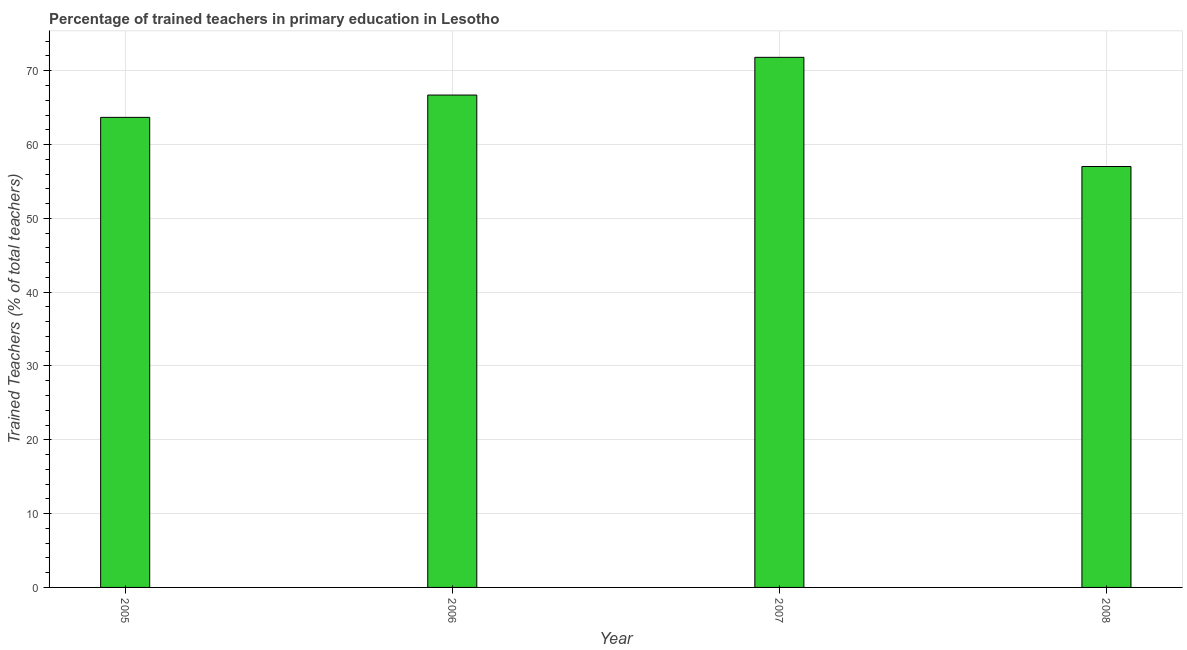Does the graph contain grids?
Ensure brevity in your answer.  Yes. What is the title of the graph?
Keep it short and to the point. Percentage of trained teachers in primary education in Lesotho. What is the label or title of the Y-axis?
Make the answer very short. Trained Teachers (% of total teachers). What is the percentage of trained teachers in 2006?
Ensure brevity in your answer.  66.7. Across all years, what is the maximum percentage of trained teachers?
Provide a short and direct response. 71.81. Across all years, what is the minimum percentage of trained teachers?
Make the answer very short. 57.02. What is the sum of the percentage of trained teachers?
Offer a terse response. 259.22. What is the difference between the percentage of trained teachers in 2005 and 2007?
Your response must be concise. -8.13. What is the average percentage of trained teachers per year?
Your response must be concise. 64.8. What is the median percentage of trained teachers?
Offer a terse response. 65.19. In how many years, is the percentage of trained teachers greater than 36 %?
Your answer should be compact. 4. What is the ratio of the percentage of trained teachers in 2005 to that in 2007?
Your response must be concise. 0.89. What is the difference between the highest and the second highest percentage of trained teachers?
Give a very brief answer. 5.11. What is the difference between the highest and the lowest percentage of trained teachers?
Give a very brief answer. 14.79. How many years are there in the graph?
Make the answer very short. 4. What is the Trained Teachers (% of total teachers) in 2005?
Keep it short and to the point. 63.68. What is the Trained Teachers (% of total teachers) in 2006?
Your answer should be compact. 66.7. What is the Trained Teachers (% of total teachers) in 2007?
Offer a very short reply. 71.81. What is the Trained Teachers (% of total teachers) of 2008?
Provide a short and direct response. 57.02. What is the difference between the Trained Teachers (% of total teachers) in 2005 and 2006?
Provide a short and direct response. -3.02. What is the difference between the Trained Teachers (% of total teachers) in 2005 and 2007?
Ensure brevity in your answer.  -8.13. What is the difference between the Trained Teachers (% of total teachers) in 2005 and 2008?
Your answer should be compact. 6.66. What is the difference between the Trained Teachers (% of total teachers) in 2006 and 2007?
Provide a succinct answer. -5.11. What is the difference between the Trained Teachers (% of total teachers) in 2006 and 2008?
Your response must be concise. 9.68. What is the difference between the Trained Teachers (% of total teachers) in 2007 and 2008?
Offer a terse response. 14.79. What is the ratio of the Trained Teachers (% of total teachers) in 2005 to that in 2006?
Offer a terse response. 0.95. What is the ratio of the Trained Teachers (% of total teachers) in 2005 to that in 2007?
Your answer should be compact. 0.89. What is the ratio of the Trained Teachers (% of total teachers) in 2005 to that in 2008?
Make the answer very short. 1.12. What is the ratio of the Trained Teachers (% of total teachers) in 2006 to that in 2007?
Give a very brief answer. 0.93. What is the ratio of the Trained Teachers (% of total teachers) in 2006 to that in 2008?
Your response must be concise. 1.17. What is the ratio of the Trained Teachers (% of total teachers) in 2007 to that in 2008?
Your answer should be very brief. 1.26. 